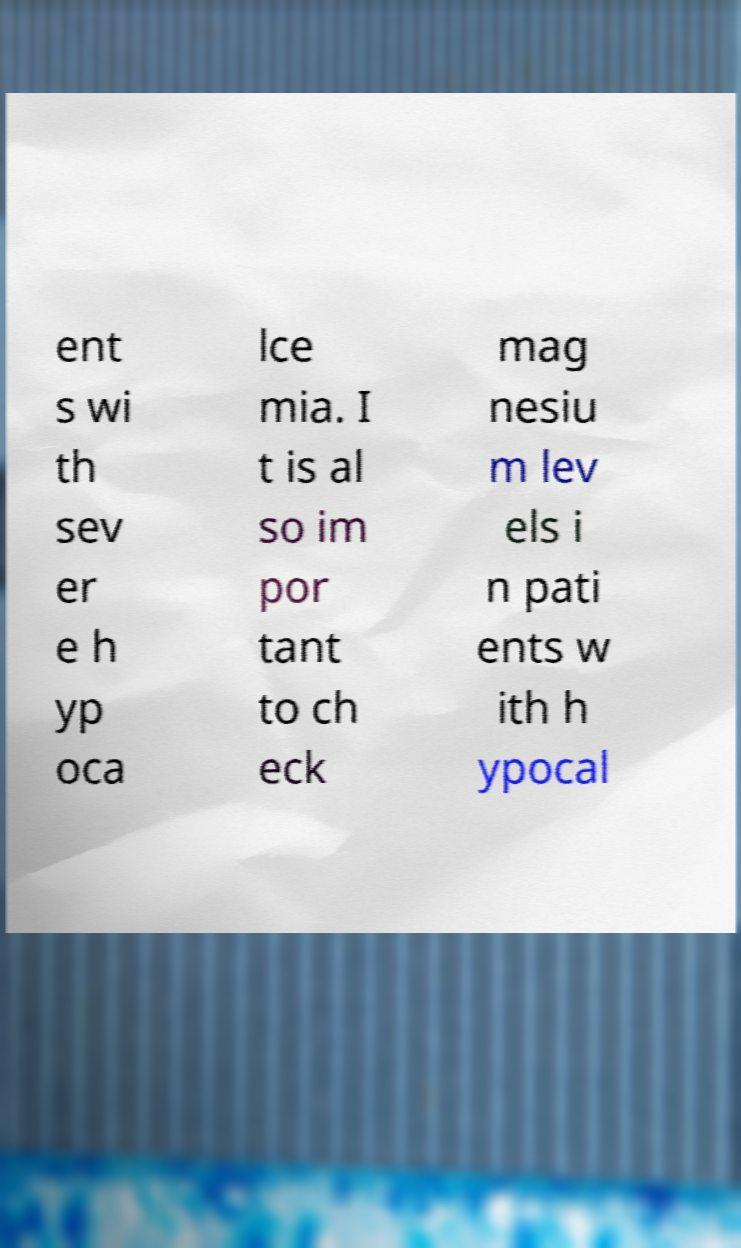What messages or text are displayed in this image? I need them in a readable, typed format. ent s wi th sev er e h yp oca lce mia. I t is al so im por tant to ch eck mag nesiu m lev els i n pati ents w ith h ypocal 